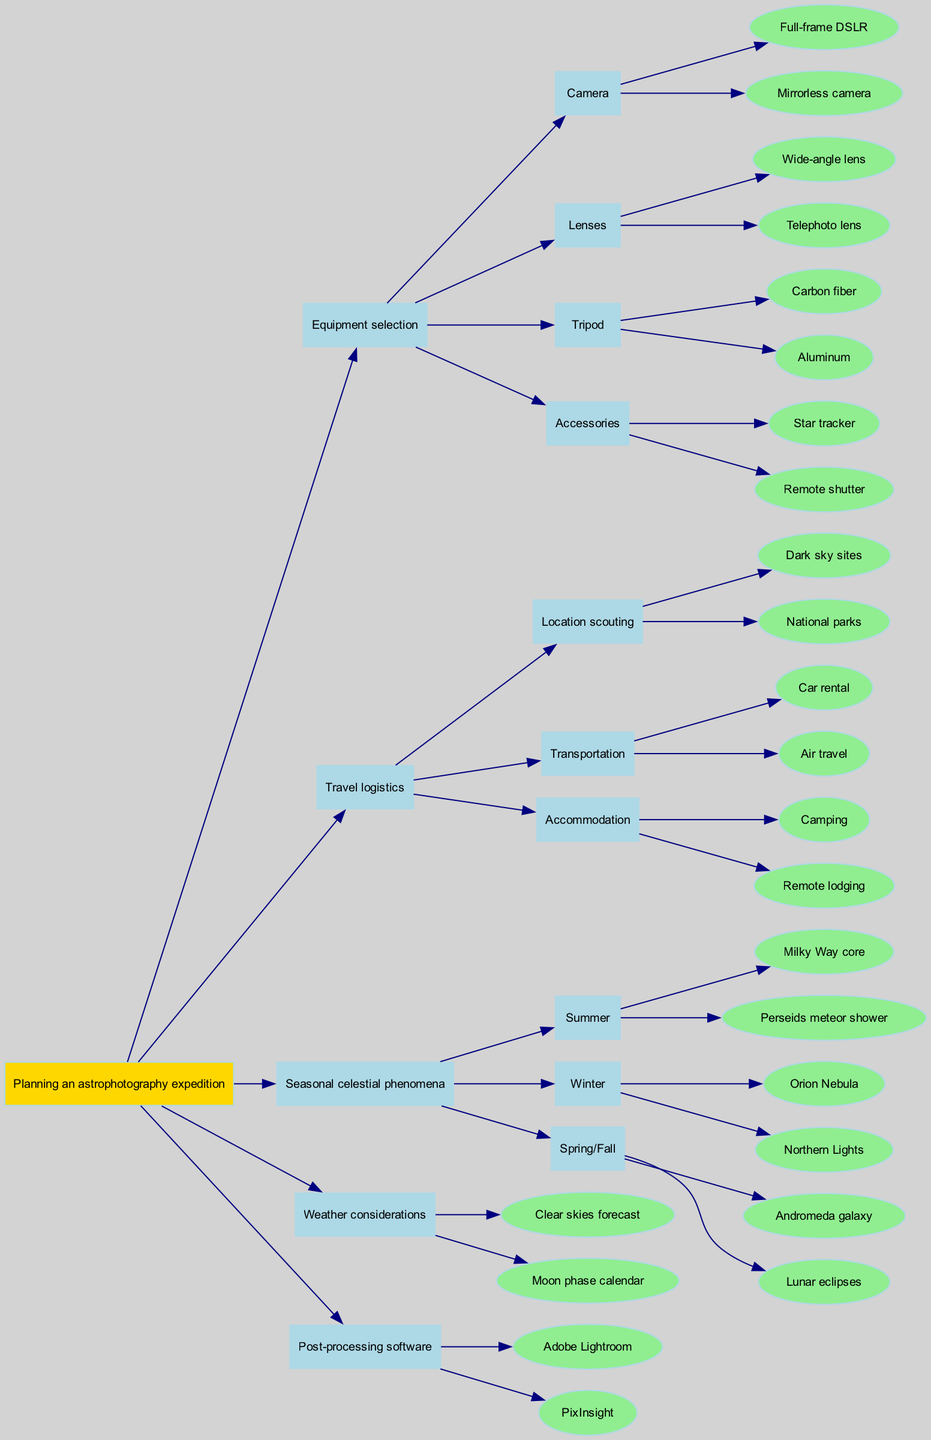What are the two types of cameras listed in the equipment selection? The diagram specifies two types of cameras under Equipment selection: "Full-frame DSLR" and "Mirrorless camera." I can locate this information directly beneath the "Camera" node in the structure.
Answer: Full-frame DSLR, Mirrorless camera How many types of tripods are mentioned? In the diagram, there are two options listed under the "Tripod" node: "Carbon fiber" and "Aluminum." This means it presents a total of two distinct types of tripods available.
Answer: 2 What is the major seasonal phenomenon for Summer? The diagram indicates that the primary seasonal phenomenon associated with Summer is the "Milky Way core." This node provides a specific example of what to expect in that season.
Answer: Milky Way core If I want to travel by car, what is one accommodation option available? Looking at the "Travel logistics" section, if "Transportation" allows for "Car rental," the corresponding accommodation option to consider is "Camping," as it can suit travelers using a car.
Answer: Camping What is the relationship between Accommodation and Transportation options in Travel logistics? The "Travel logistics" section contains separate nodes for “Transportation” and “Accommodation,” with multiple options under each. Both nodes are connected to show that they are part of the overall travel planning, demonstrating a direct relationship where travel decisions (like how to get there) influence accommodation choices.
Answer: Related Which weather consideration should be checked before going on an expedition? The diagram mentions two weather considerations, one of which is the "Clear skies forecast." This would be an essential check before planning an astrophotography expedition as it affects visibility.
Answer: Clear skies forecast What type of lens is categorized under Equipment selection for capturing wide landscapes? Under the "Lenses" node, the diagram lists "Wide-angle lens," making it clear that this type of lens is recommended for capturing expansive night sky images like landscapes of the Milky Way.
Answer: Wide-angle lens During which season can I expect to see the Northern Lights? According to the "Seasonal celestial phenomena" section of the diagram, the Northern Lights are specifically mentioned as a winter phenomenon, indicating this is the best time to view them.
Answer: Winter What are the accessories mentioned for astrophotography? The Accessories node mentions two items: "Star tracker" and "Remote shutter." These items are important tools that support astrophotography efforts beyond just the camera and lens.
Answer: Star tracker, Remote shutter 